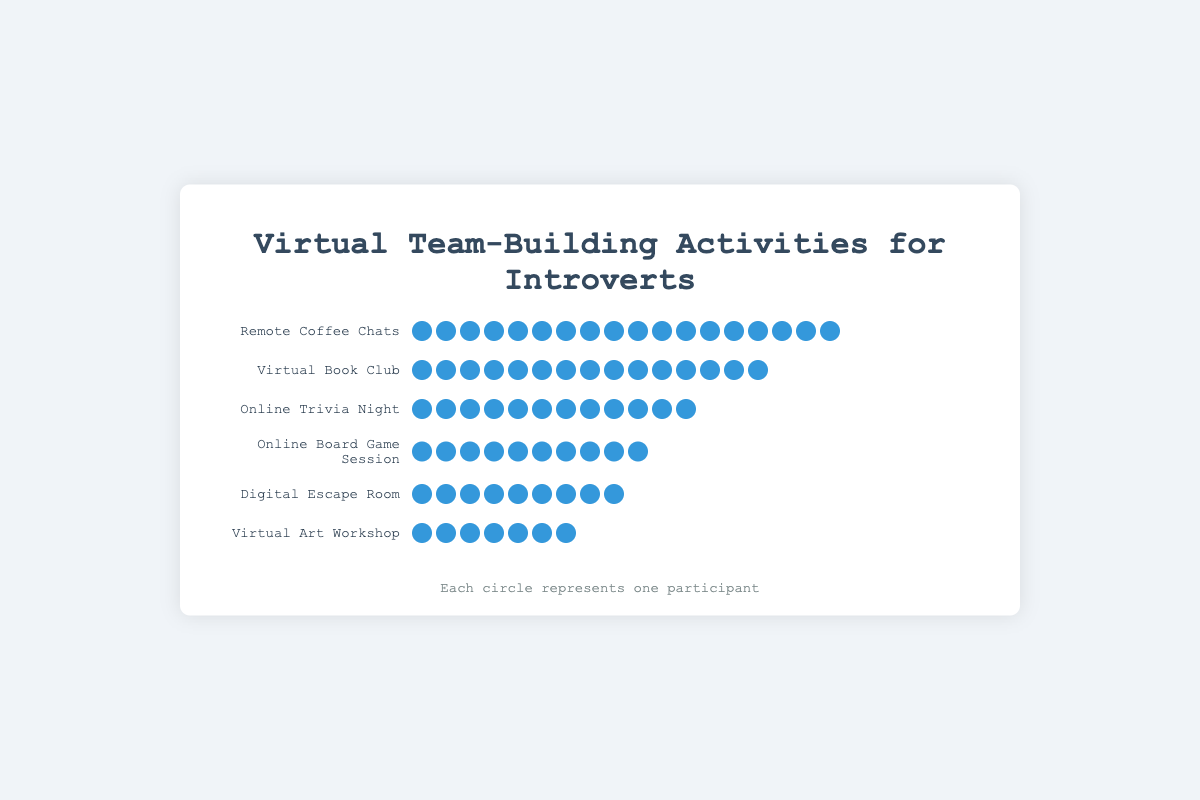Which activity has the highest participation rate? By counting the icons representing participants, "Remote Coffee Chats" has the highest count of icons, which is 18
Answer: Remote Coffee Chats Which activity has the lowest participation rate? By counting the icons representing participants, "Virtual Art Workshop" has the lowest count of icons, which is 7
Answer: Virtual Art Workshop How many more participants does "Remote Coffee Chats" have compared to "Virtual Art Workshop"? "Remote Coffee Chats" has 18 participants and "Virtual Art Workshop" has 7 participants. The difference is 18 - 7 = 11
Answer: 11 Which activity has a participation rate close to "Online Board Game Session"? By comparing the number of participant icons, "Online Trivia Night" has a similar participation rate to "Online Board Game Session". "Online Trivia Night" has 12 participants, and "Online Board Game Session" has 10 participants
Answer: Online Trivia Night What is the total number of participants across all activities? Sum of participants: 15 (Virtual Book Club) + 12 (Online Trivia Night) + 9 (Digital Escape Room) + 18 (Remote Coffee Chats) + 7 (Virtual Art Workshop) + 10 (Online Board Game Session) = 71
Answer: 71 